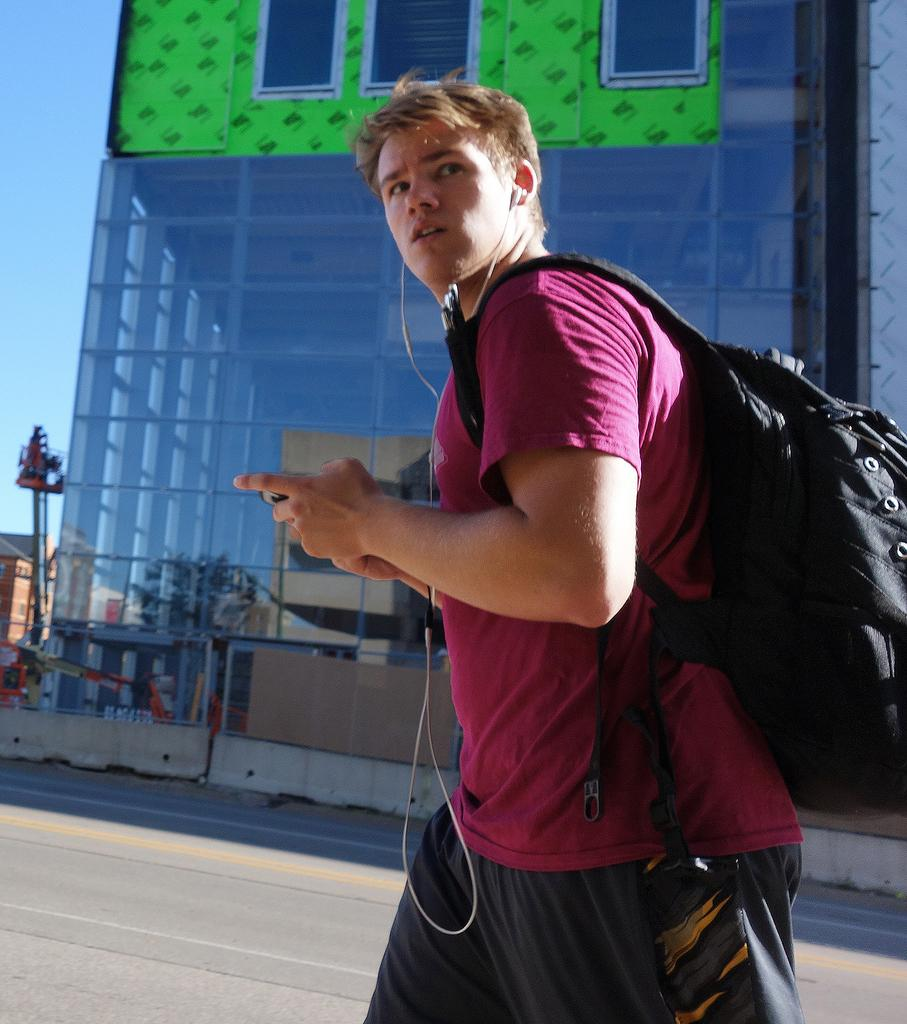What can be seen in the background of the image? There is a building in the background of the image. Who is present in the image? There is a man in the image. What is the man wearing? The man is wearing a backpack. What is the man holding in his hands? The man is holding a mobile in his hands. What is at the bottom of the image? There is a road at the bottom of the image. Can you see a star shining brightly in the image? There is no star visible in the image. What type of motion is the yam performing in the image? There is no yam present in the image, so it cannot be performing any motion. 